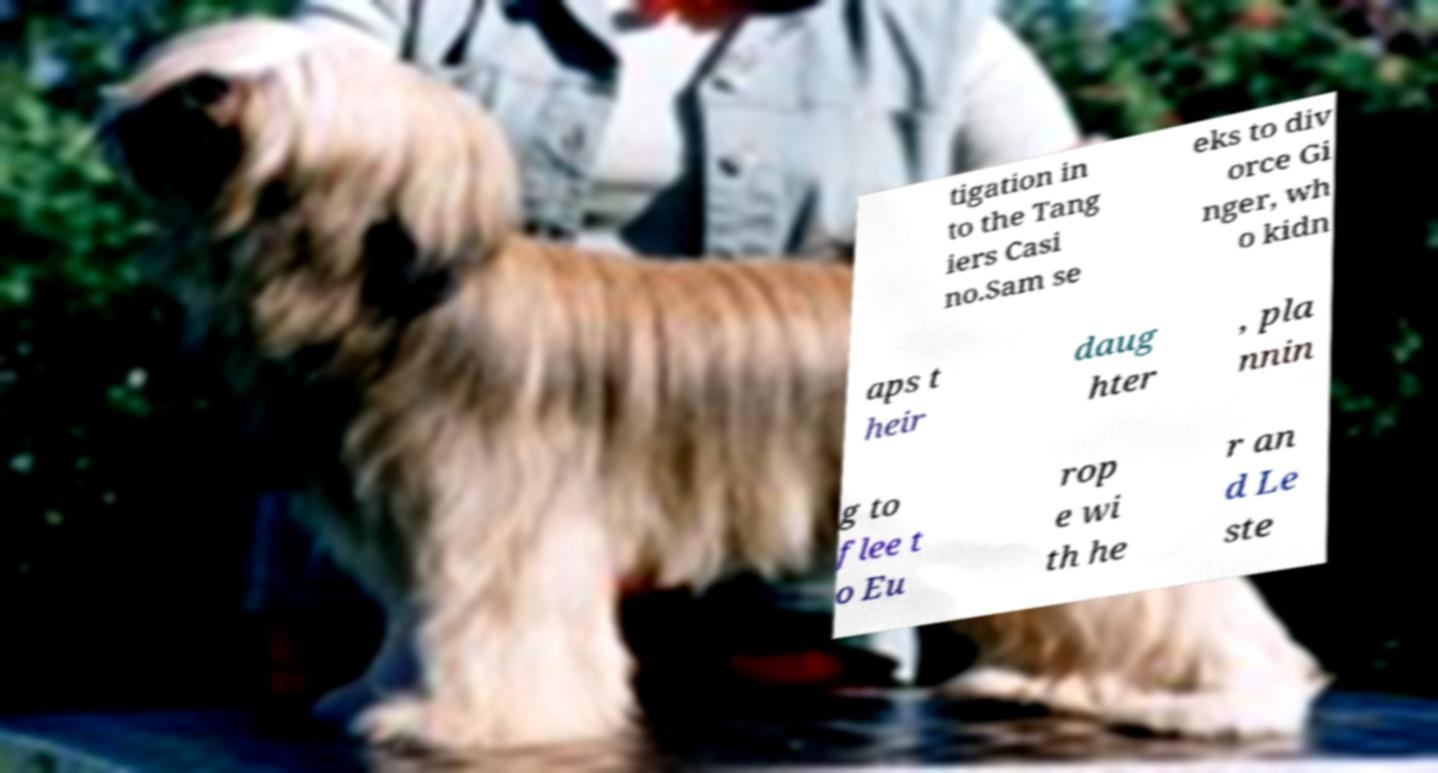Please read and relay the text visible in this image. What does it say? tigation in to the Tang iers Casi no.Sam se eks to div orce Gi nger, wh o kidn aps t heir daug hter , pla nnin g to flee t o Eu rop e wi th he r an d Le ste 